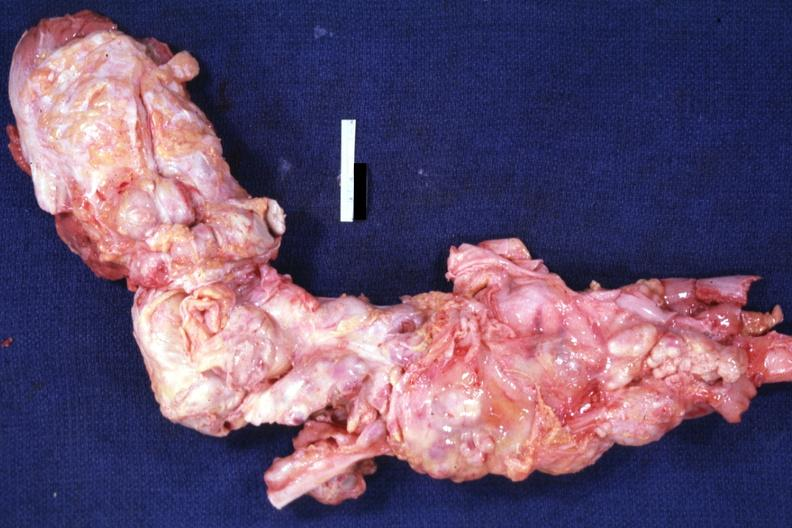how is aorta not opened surrounded by nodes?
Answer the question using a single word or phrase. Large 